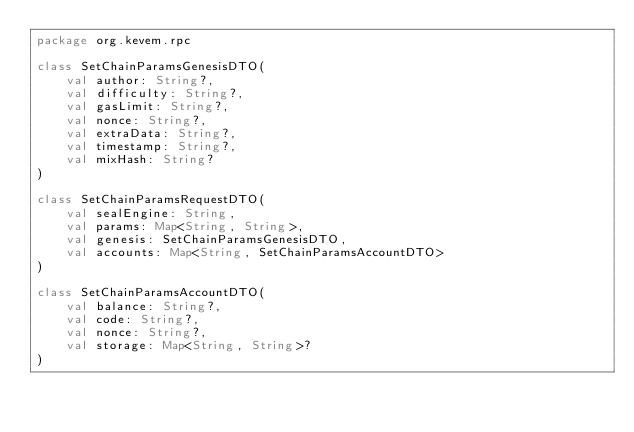Convert code to text. <code><loc_0><loc_0><loc_500><loc_500><_Kotlin_>package org.kevem.rpc

class SetChainParamsGenesisDTO(
    val author: String?,
    val difficulty: String?,
    val gasLimit: String?,
    val nonce: String?,
    val extraData: String?,
    val timestamp: String?,
    val mixHash: String?
)

class SetChainParamsRequestDTO(
    val sealEngine: String,
    val params: Map<String, String>,
    val genesis: SetChainParamsGenesisDTO,
    val accounts: Map<String, SetChainParamsAccountDTO>
)

class SetChainParamsAccountDTO(
    val balance: String?,
    val code: String?,
    val nonce: String?,
    val storage: Map<String, String>?
)</code> 